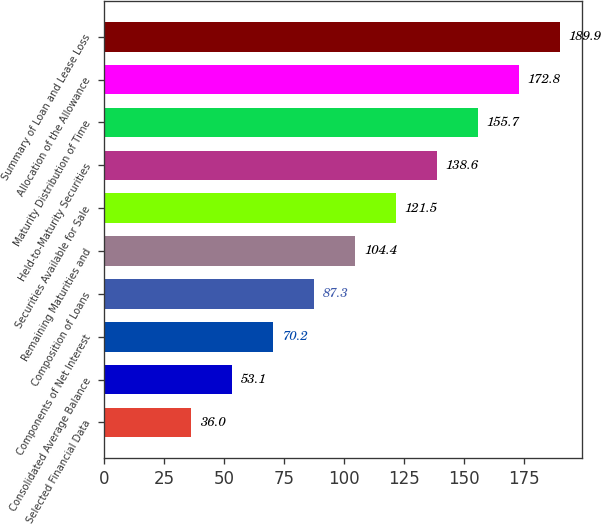<chart> <loc_0><loc_0><loc_500><loc_500><bar_chart><fcel>Selected Financial Data<fcel>Consolidated Average Balance<fcel>Components of Net Interest<fcel>Composition of Loans<fcel>Remaining Maturities and<fcel>Securities Available for Sale<fcel>Held-to-Maturity Securities<fcel>Maturity Distribution of Time<fcel>Allocation of the Allowance<fcel>Summary of Loan and Lease Loss<nl><fcel>36<fcel>53.1<fcel>70.2<fcel>87.3<fcel>104.4<fcel>121.5<fcel>138.6<fcel>155.7<fcel>172.8<fcel>189.9<nl></chart> 